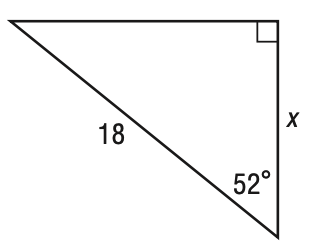Answer the mathemtical geometry problem and directly provide the correct option letter.
Question: What is the value of x in the figure below? Round to the nearest tenth.
Choices: A: 10.5 B: 11.1 C: 13.6 D: 14.2 B 